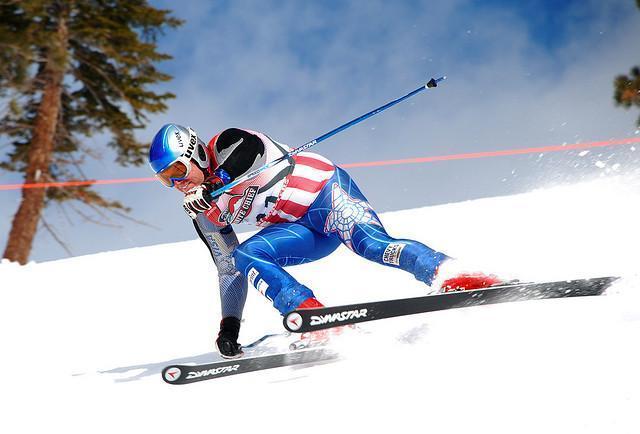How many ski are there?
Give a very brief answer. 1. 